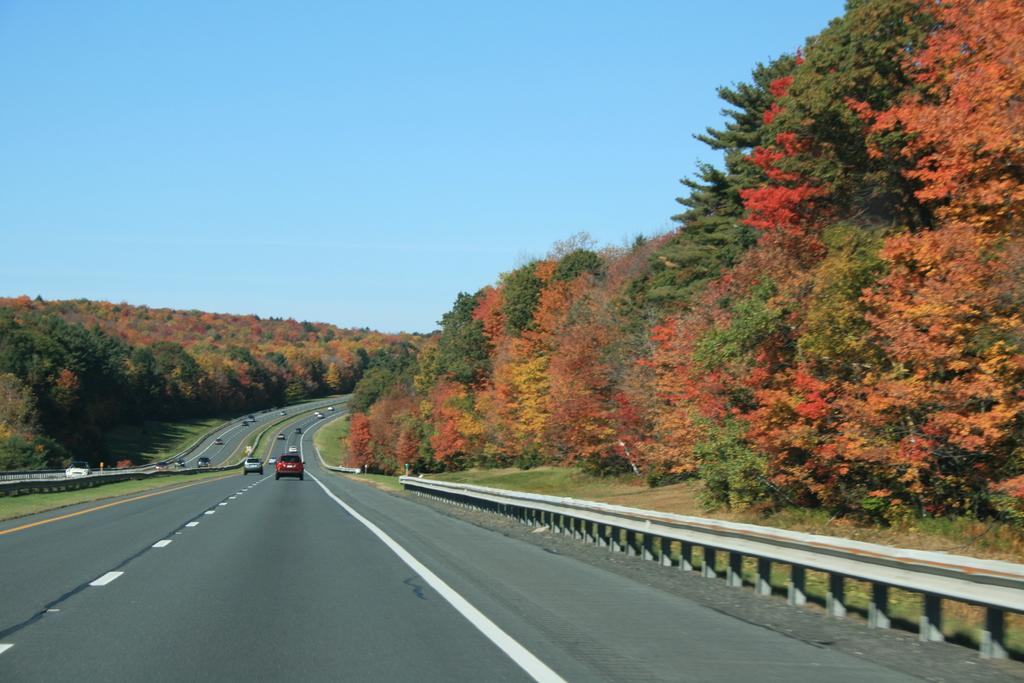What is the main subject of the image? The main subject of the image is a highway. What can be observed about the vehicles on the highway? Many vehicles are moving on the road. What type of vegetation is present alongside the highway? There are beautiful trees on either side of the road. What type of account can be seen being used by the trees to communicate with each other in the image? There is no account or communication between the trees in the image; they are simply trees alongside the highway. 